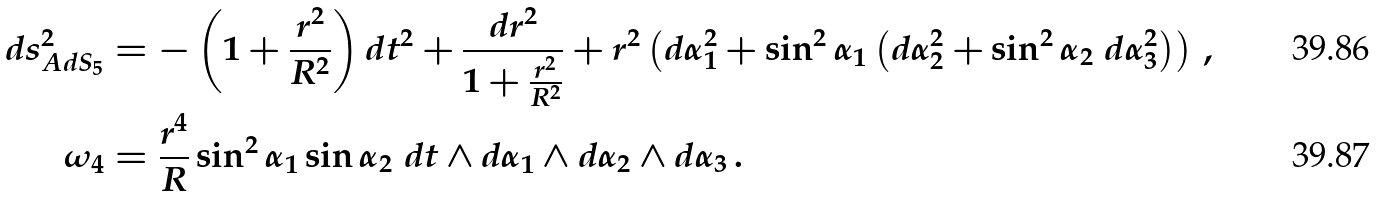Convert formula to latex. <formula><loc_0><loc_0><loc_500><loc_500>d s ^ { 2 } _ { A d S _ { 5 } } & = - \left ( 1 + \frac { r ^ { 2 } } { R ^ { 2 } } \right ) d t ^ { 2 } + \frac { d r ^ { 2 } } { 1 + \frac { r ^ { 2 } } { R ^ { 2 } } } + r ^ { 2 } \left ( d \alpha _ { 1 } ^ { 2 } + \sin ^ { 2 } \alpha _ { 1 } \left ( d \alpha _ { 2 } ^ { 2 } + \sin ^ { 2 } \alpha _ { 2 } \ d \alpha _ { 3 } ^ { 2 } \right ) \right ) \, , \\ \omega _ { 4 } & = \frac { r ^ { 4 } } { R } \sin ^ { 2 } \alpha _ { 1 } \sin \alpha _ { 2 } \ d t \wedge d \alpha _ { 1 } \wedge d \alpha _ { 2 } \wedge d \alpha _ { 3 } \, .</formula> 